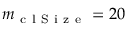<formula> <loc_0><loc_0><loc_500><loc_500>m _ { c l S i z e } = 2 0</formula> 